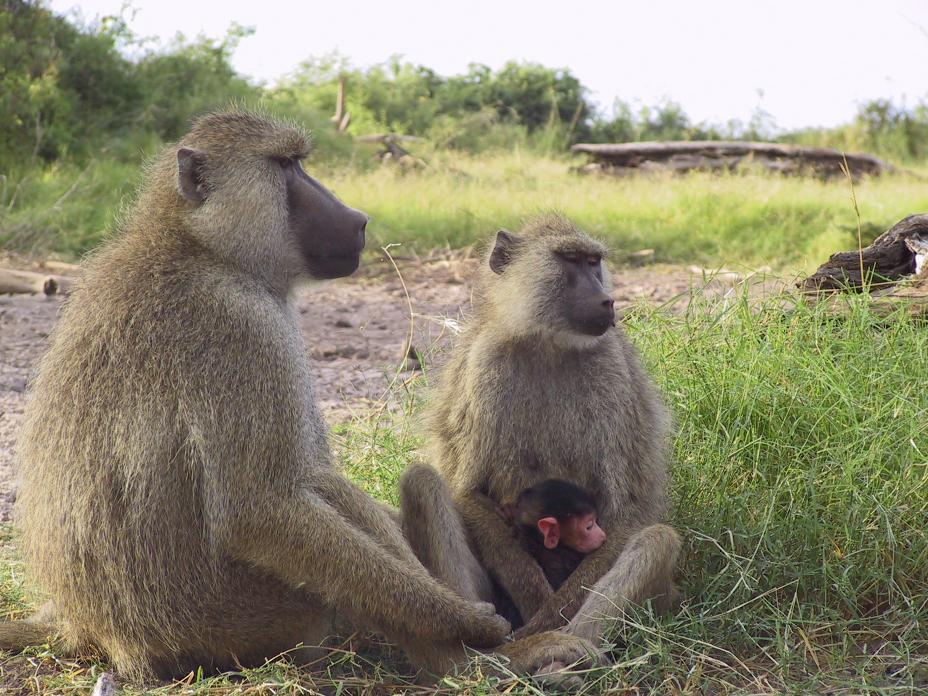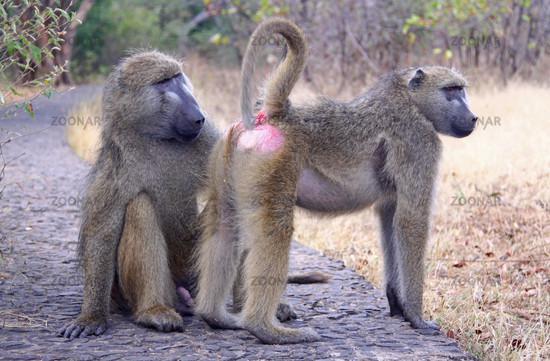The first image is the image on the left, the second image is the image on the right. Evaluate the accuracy of this statement regarding the images: "One monkey is holding onto another monkey from it's back in one of the images.". Is it true? Answer yes or no. No. 